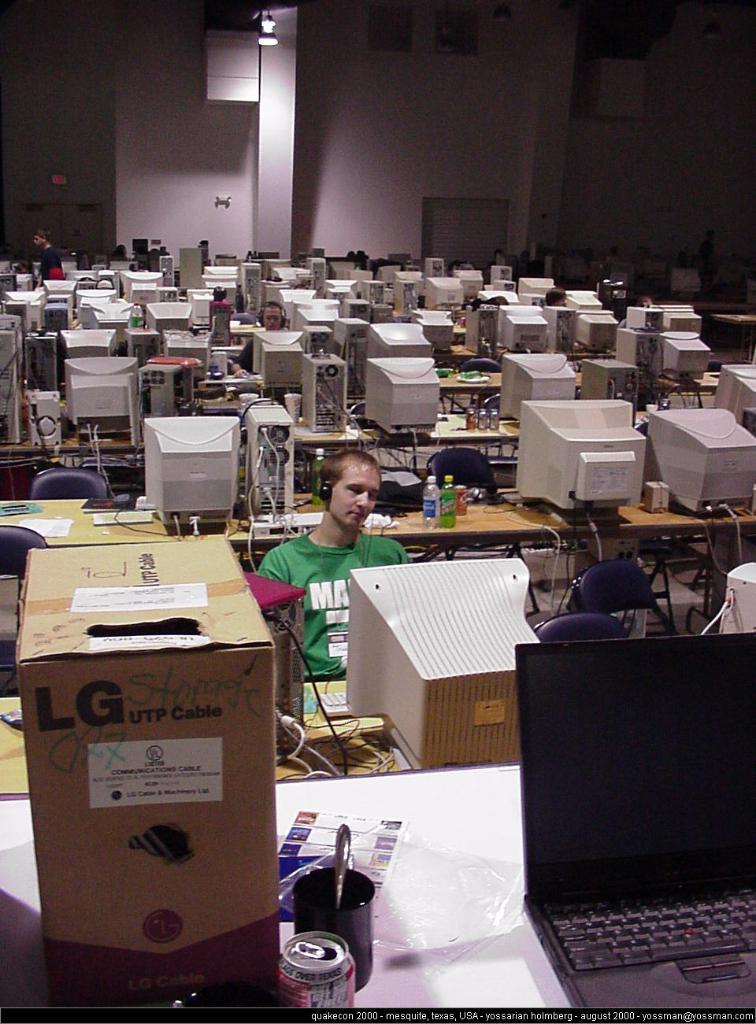What brand is on the cable box?
Offer a terse response. Lg. What letter can be seen on the green t-shirt?
Offer a very short reply. M. 